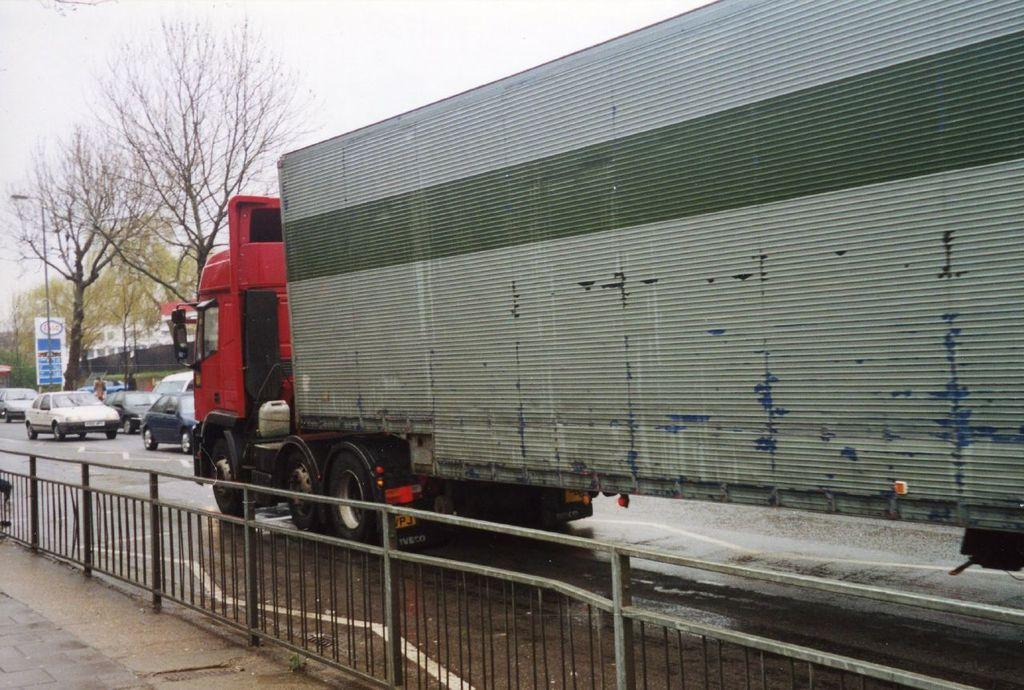What type of vehicle is in the image? There is a vehicle in the image, but the specific type is not mentioned. What colors can be seen on the vehicle? The vehicle has red and gray colors. Are there any other vehicles in the image? Yes, there are other vehicles on the road in the image. What is the color of the trees in the image? The trees have green color in the image. What is visible in the sky in the image? The sky is visible in the image, and it appears to be white. Can you tell me how many quarters are on the ground in the image? There is no mention of quarters or any coins in the image. 